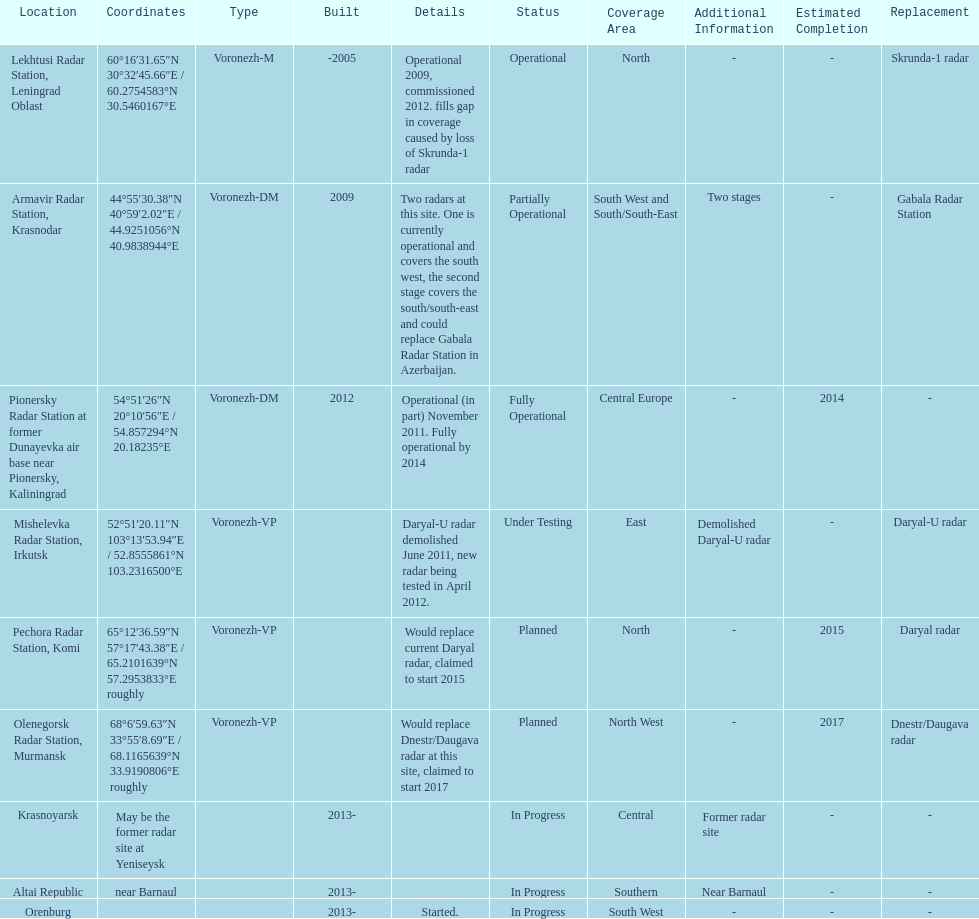Write the full table. {'header': ['Location', 'Coordinates', 'Type', 'Built', 'Details', 'Status', 'Coverage Area', 'Additional Information', 'Estimated Completion', 'Replacement'], 'rows': [['Lekhtusi Radar Station, Leningrad Oblast', '60°16′31.65″N 30°32′45.66″E\ufeff / \ufeff60.2754583°N 30.5460167°E', 'Voronezh-M', '-2005', 'Operational 2009, commissioned 2012. fills gap in coverage caused by loss of Skrunda-1 radar', 'Operational', 'North', '-', '-', 'Skrunda-1 radar'], ['Armavir Radar Station, Krasnodar', '44°55′30.38″N 40°59′2.02″E\ufeff / \ufeff44.9251056°N 40.9838944°E', 'Voronezh-DM', '2009', 'Two radars at this site. One is currently operational and covers the south west, the second stage covers the south/south-east and could replace Gabala Radar Station in Azerbaijan.', 'Partially Operational', 'South West and South/South-East', 'Two stages', '-', 'Gabala Radar Station'], ['Pionersky Radar Station at former Dunayevka air base near Pionersky, Kaliningrad', '54°51′26″N 20°10′56″E\ufeff / \ufeff54.857294°N 20.18235°E', 'Voronezh-DM', '2012', 'Operational (in part) November 2011. Fully operational by 2014', 'Fully Operational', 'Central Europe', '-', '2014', '-'], ['Mishelevka Radar Station, Irkutsk', '52°51′20.11″N 103°13′53.94″E\ufeff / \ufeff52.8555861°N 103.2316500°E', 'Voronezh-VP', '', 'Daryal-U radar demolished June 2011, new radar being tested in April 2012.', 'Under Testing', 'East', 'Demolished Daryal-U radar', '-', 'Daryal-U radar'], ['Pechora Radar Station, Komi', '65°12′36.59″N 57°17′43.38″E\ufeff / \ufeff65.2101639°N 57.2953833°E roughly', 'Voronezh-VP', '', 'Would replace current Daryal radar, claimed to start 2015', 'Planned', 'North', '-', '2015', 'Daryal radar'], ['Olenegorsk Radar Station, Murmansk', '68°6′59.63″N 33°55′8.69″E\ufeff / \ufeff68.1165639°N 33.9190806°E roughly', 'Voronezh-VP', '', 'Would replace Dnestr/Daugava radar at this site, claimed to start 2017', 'Planned', 'North West', '-', '2017', 'Dnestr/Daugava radar'], ['Krasnoyarsk', 'May be the former radar site at Yeniseysk', '', '2013-', '', 'In Progress', 'Central', 'Former radar site', '-', '-'], ['Altai Republic', 'near Barnaul', '', '2013-', '', 'In Progress', 'Southern', 'Near Barnaul', '-', '-'], ['Orenburg', '', '', '2013-', 'Started.', 'In Progress', 'South West', '-', '-', '-']]} What is the only location with a coordination of 60°16&#8242;31.65&#8243;n 30°32&#8242;45.66&#8243;e / 60.2754583°n 30.5460167°e? Lekhtusi Radar Station, Leningrad Oblast. 